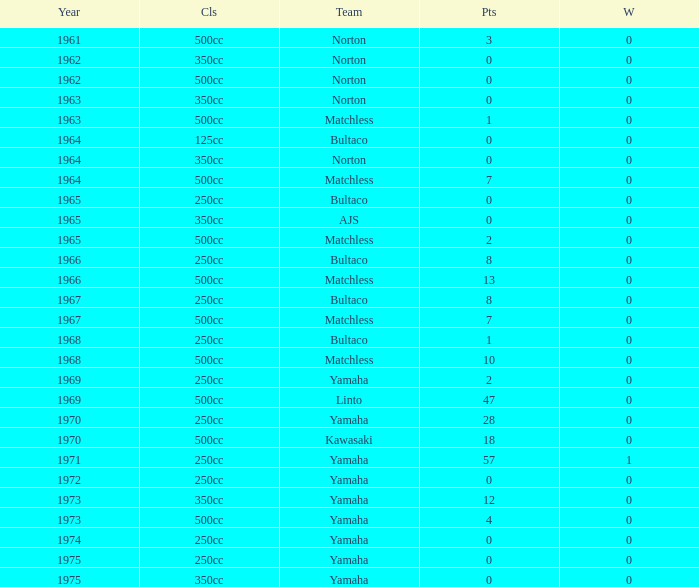What is the sum of all points in 1975 with 0 wins? None. 